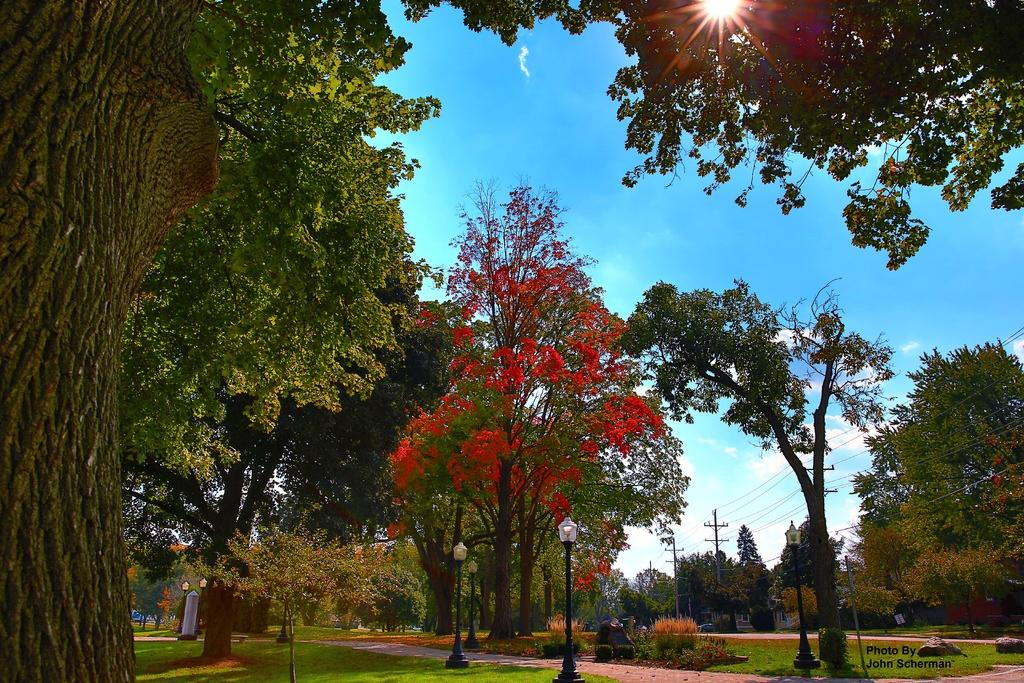What type of natural elements can be seen in the image? There are trees in the image. What type of artificial elements can be seen in the image? There are lights, poles, and wires in the image. Where are the poles and wires located in the image? They are in the right corner of the image. What is written in the right bottom corner of the image? There is something written in the right bottom corner of the image. Can you tell me how many chickens are perched on the trees in the image? There are no chickens present in the image; it features trees, lights, poles, wires, and written text. What type of insurance policy is mentioned in the image? There is no mention of insurance in the image. 